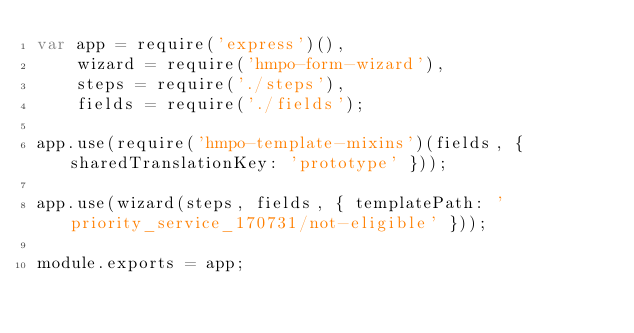<code> <loc_0><loc_0><loc_500><loc_500><_JavaScript_>var app = require('express')(),
    wizard = require('hmpo-form-wizard'),
    steps = require('./steps'),
    fields = require('./fields');

app.use(require('hmpo-template-mixins')(fields, { sharedTranslationKey: 'prototype' }));

app.use(wizard(steps, fields, { templatePath: 'priority_service_170731/not-eligible' }));

module.exports = app;
</code> 